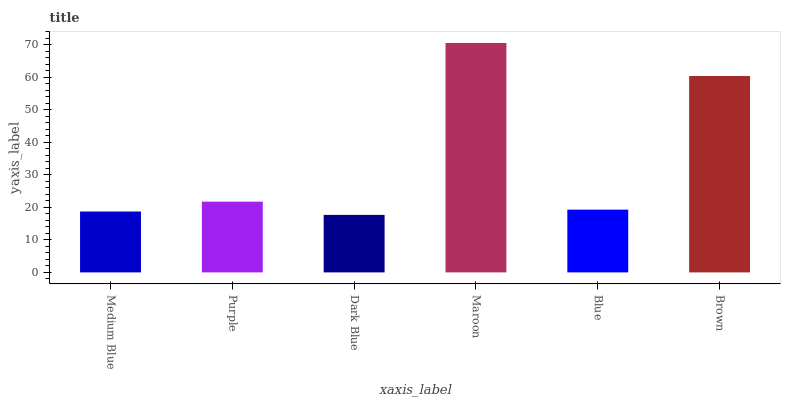Is Dark Blue the minimum?
Answer yes or no. Yes. Is Maroon the maximum?
Answer yes or no. Yes. Is Purple the minimum?
Answer yes or no. No. Is Purple the maximum?
Answer yes or no. No. Is Purple greater than Medium Blue?
Answer yes or no. Yes. Is Medium Blue less than Purple?
Answer yes or no. Yes. Is Medium Blue greater than Purple?
Answer yes or no. No. Is Purple less than Medium Blue?
Answer yes or no. No. Is Purple the high median?
Answer yes or no. Yes. Is Blue the low median?
Answer yes or no. Yes. Is Blue the high median?
Answer yes or no. No. Is Medium Blue the low median?
Answer yes or no. No. 